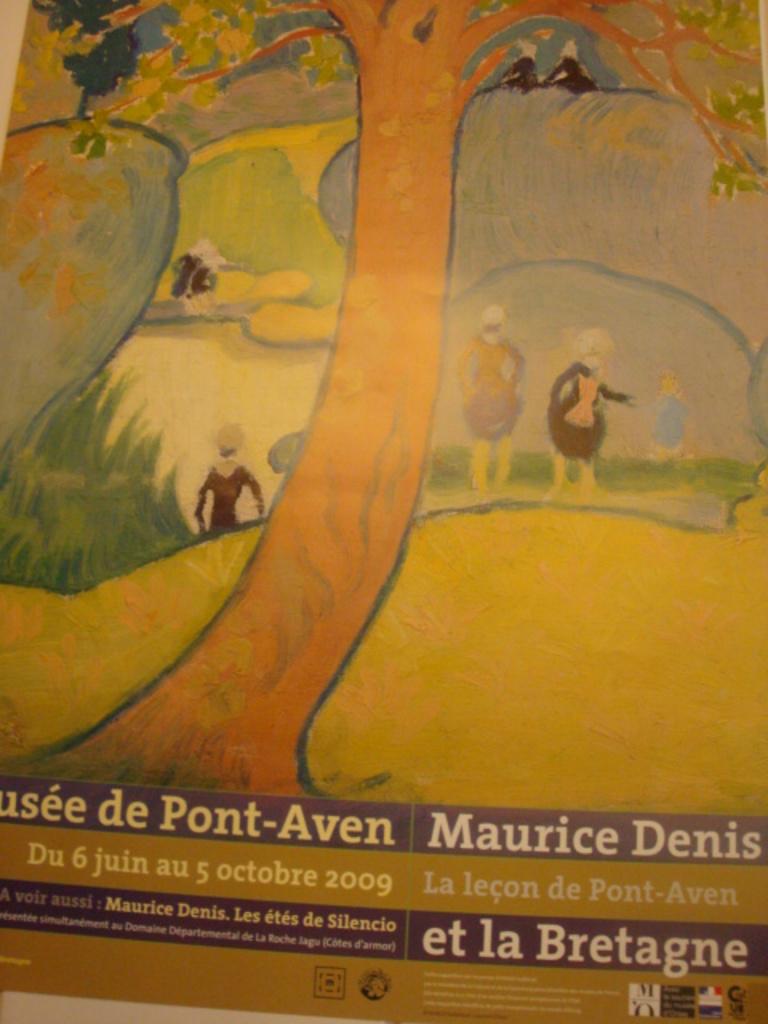What is the name on the image in the top banner, right hand side of the image?
Offer a very short reply. Maurice denis. What year was the book made?
Your answer should be compact. 2009. 